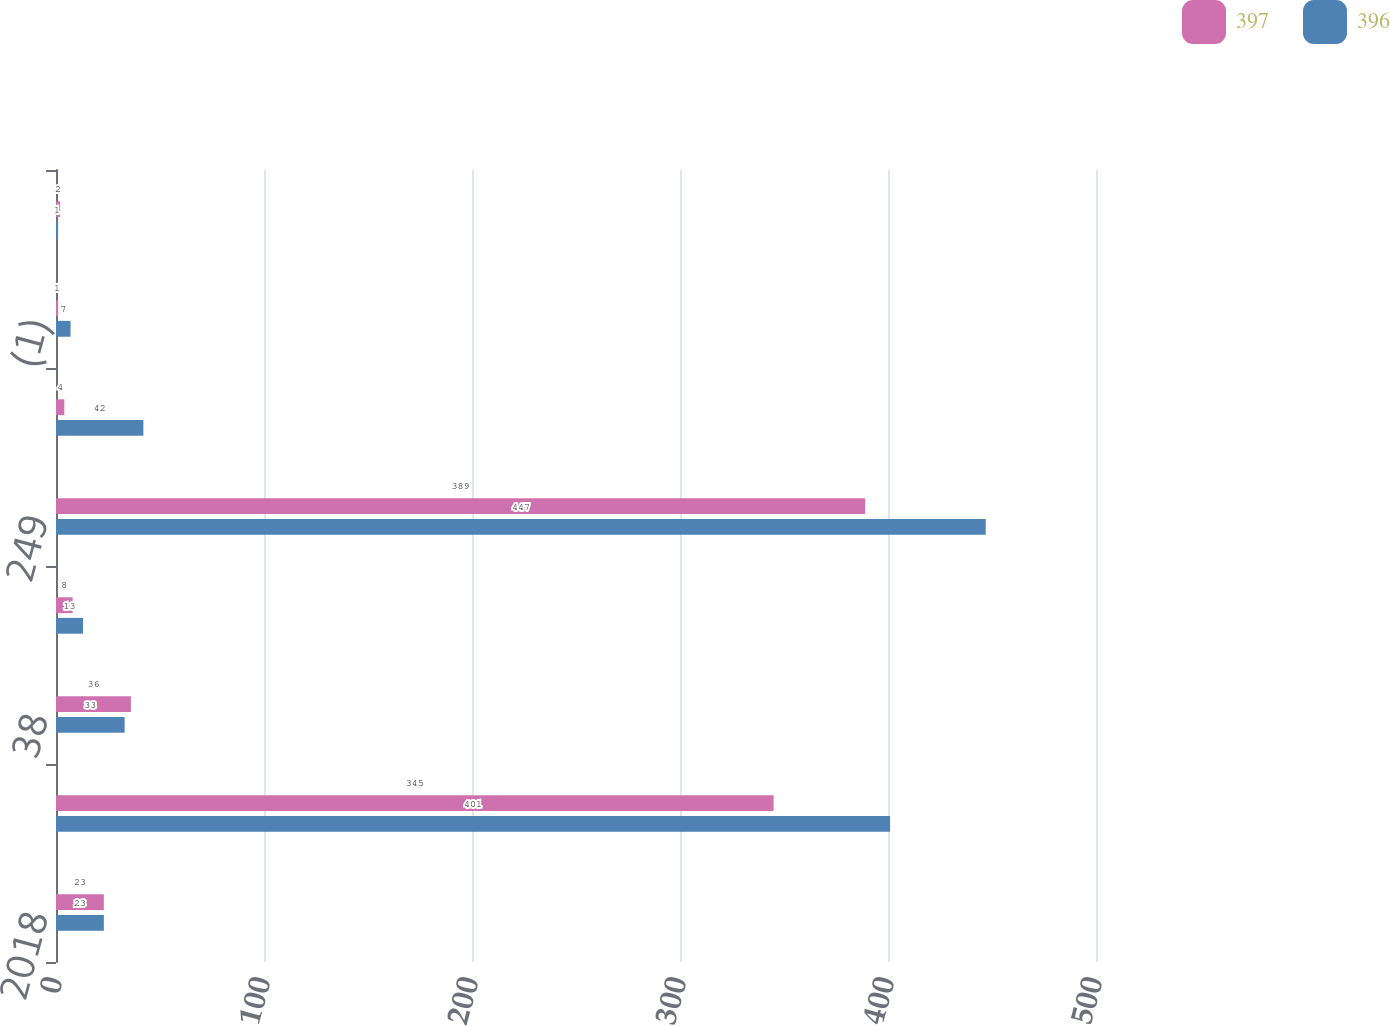Convert chart. <chart><loc_0><loc_0><loc_500><loc_500><stacked_bar_chart><ecel><fcel>2018<fcel>197<fcel>38<fcel>14<fcel>249<fcel>44<fcel>(1)<fcel>-<nl><fcel>397<fcel>23<fcel>345<fcel>36<fcel>8<fcel>389<fcel>4<fcel>1<fcel>2<nl><fcel>396<fcel>23<fcel>401<fcel>33<fcel>13<fcel>447<fcel>42<fcel>7<fcel>1<nl></chart> 